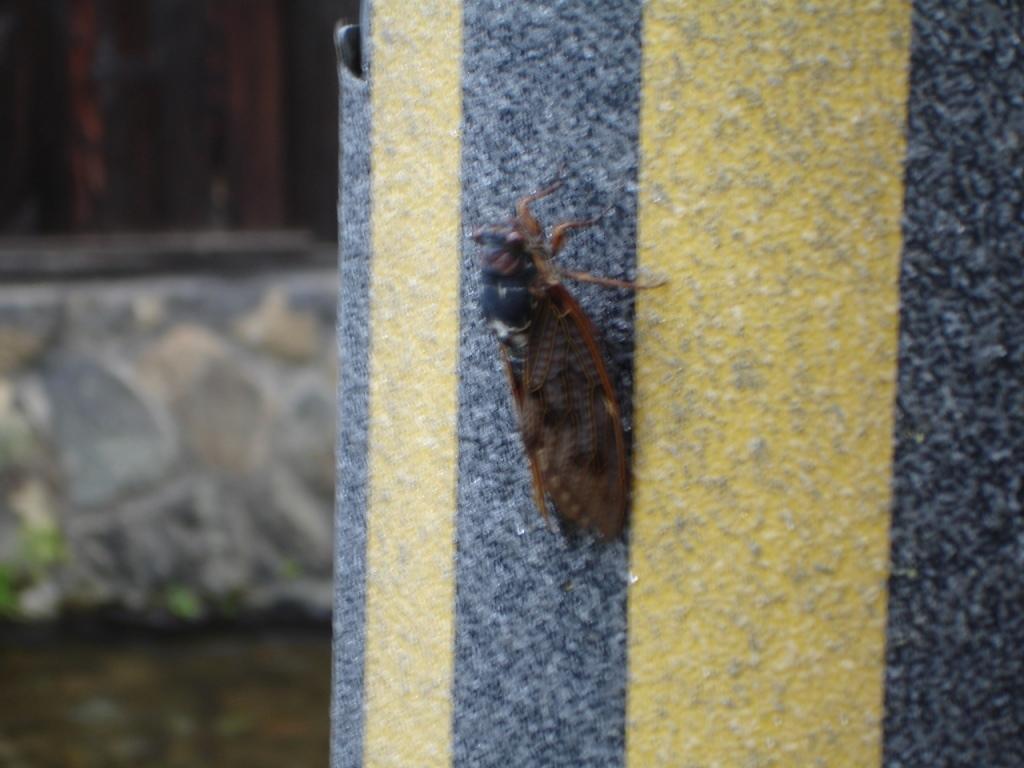Could you give a brief overview of what you see in this image? In this image we can see an insect on the wall and a blurry background. 